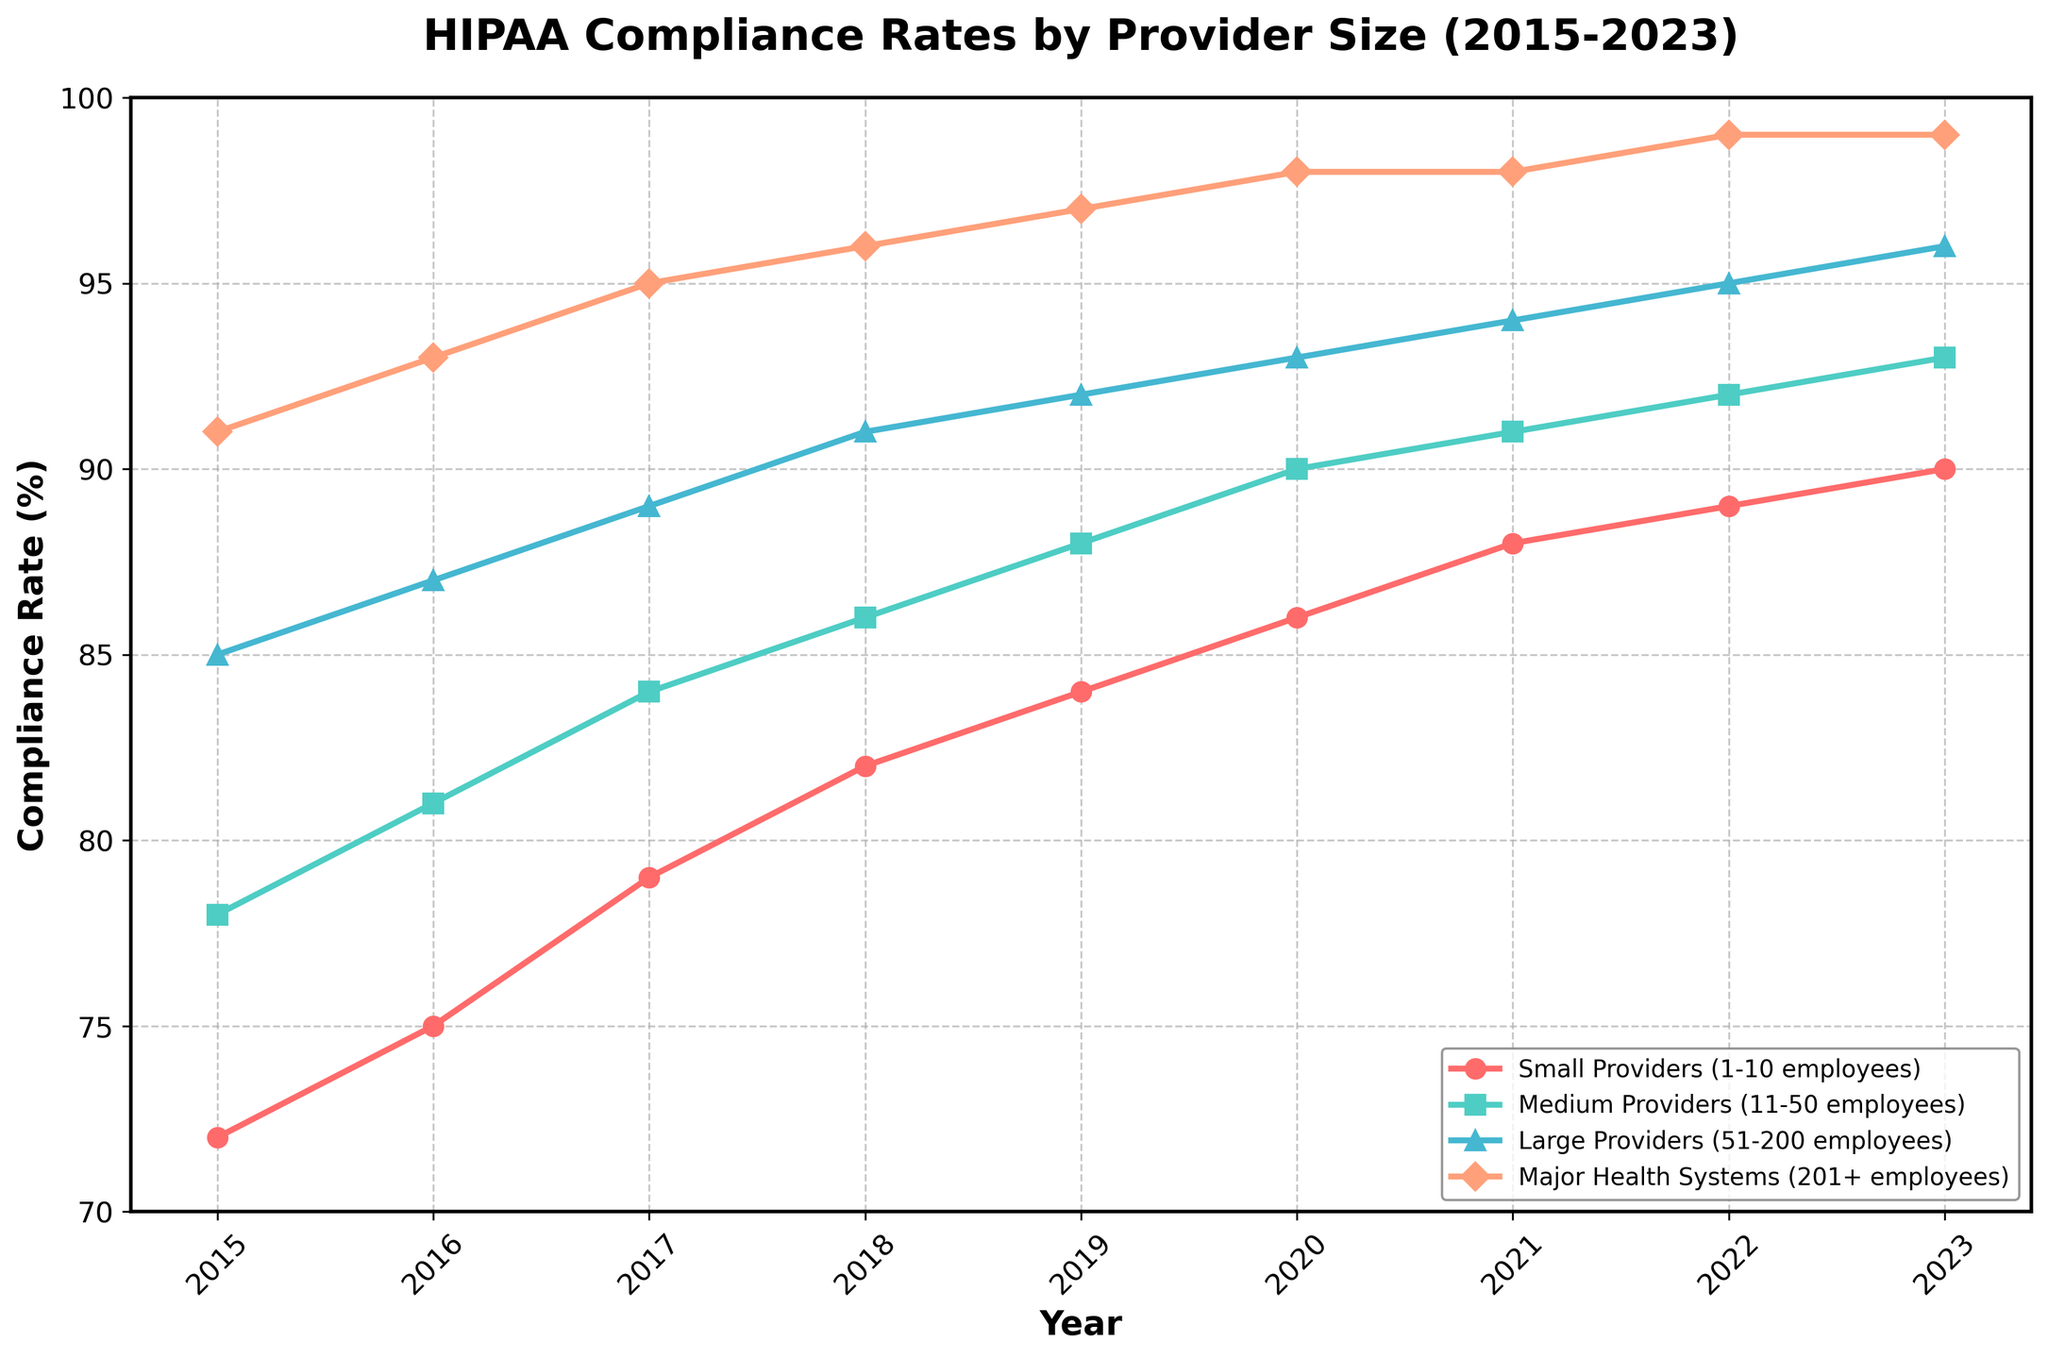What was the compliance rate for Medium Providers in 2020? Locate the year 2020 on the x-axis, then find the point on the Medium Providers line (green) corresponding to that year. The y-axis value at that point is the compliance rate.
Answer: 90 Which provider size had the highest compliance rate consistently over the years? Observe the lines on the graph for all years and identify which line is consistently at the top. The Major Health Systems (orange) line remains the highest throughout the years.
Answer: Major Health Systems How much did the compliance rate for Small Providers increase from 2015 to 2023? Find the compliance rates for Small Providers (red) in 2015 and 2023. Subtract the 2015 value from the 2023 value: \( 90 - 72 = 18 \).
Answer: 18 In what year did Large Providers reach a 90% compliance rate? Focus on the line for Large Providers (blue) and find the year where the value first hits 90% on the y-axis. This occurs in 2018.
Answer: 2018 Which provider category saw the greatest total improvement in compliance rate from 2015 to 2023? Calculate the improvement for each provider category by subtracting the 2015 compliance rate from the 2023 compliance rate. Determine which value is the greatest. The improvements are: Small Providers: \(90-72\), Medium Providers: \(93-78\), Large Providers: \(96-85\), Major Health Systems: \(99-91\). The largest improvement is for Small Providers (\(18\)).
Answer: Small Providers What is the average compliance rate of Medium Providers for the years shown? Add the compliance rates of Medium Providers for each year and divide by the number of years: \(\frac{78+81+84+86+88+90+91+92+93}{9} = 87 \).
Answer: 87 By how many percentage points did the compliance rates for Major Health Systems change from 2018 to 2019? Find the compliance rates for Major Health Systems in 2018 and 2019. Subtract the 2018 value from the 2019 value: \(97 - 96 = 1 \).
Answer: 1 In which year did the compliance rates for all provider sizes except Small Providers reach at least 90%? Look at the lines for Medium, Large, and Major Health Systems to find the first year in which all three reached at least 90%. This is 2020.
Answer: 2020 Compare the compliance rate trend for Small Providers and Medium Providers. Which group's compliance rate increased more steadily over the years? Observe the slopes of the lines for both Small Providers and Medium Providers. Use the fact that Medium Providers' line (green) shows a more consistent, steady increase compared to the faster rising Small Providers (red) line over some years.
Answer: Medium Providers 